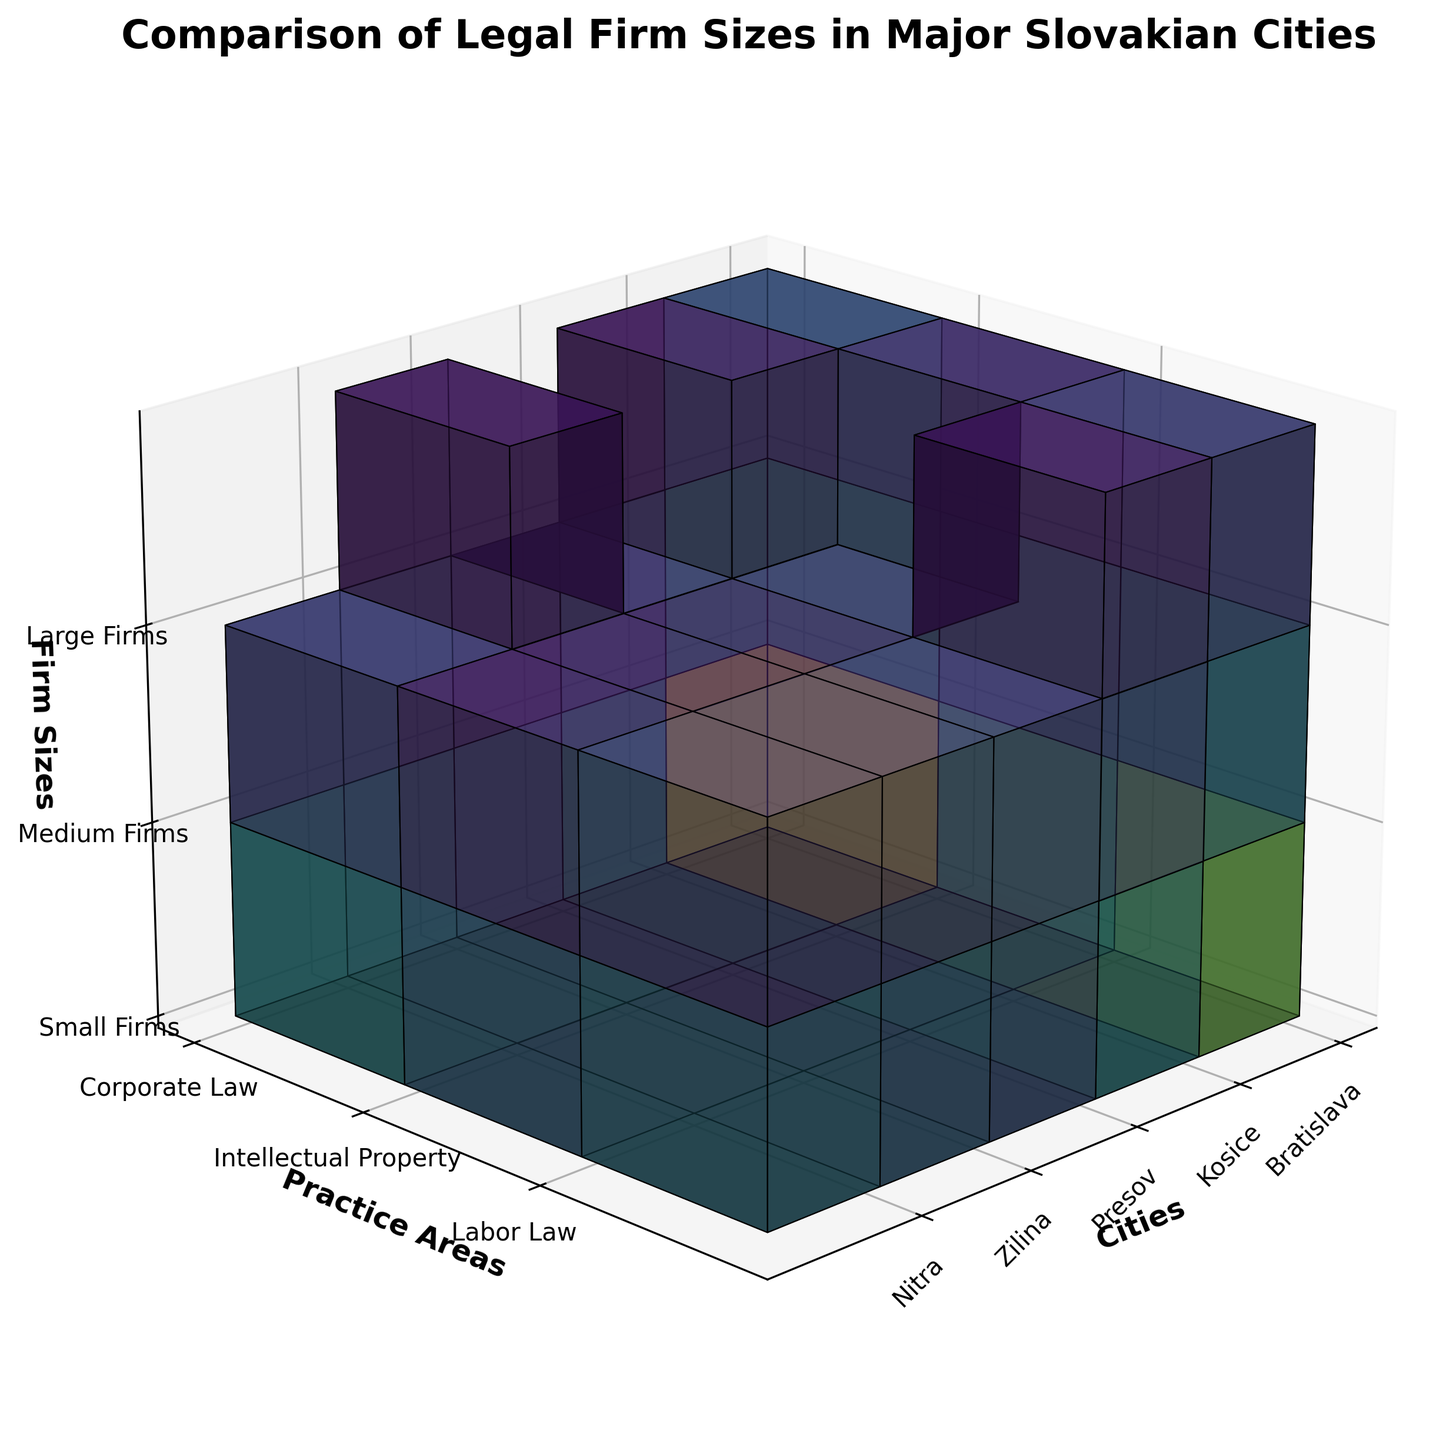What cities are compared in the figure? The x-axis represents the cities compared in the figure. By looking at the labels on this axis, we can see the cities are Bratislava, Kosice, Presov, Zilina, and Nitra.
Answer: Bratislava, Kosice, Presov, Zilina, Nitra Which city has the highest number of small firms in Corporate Law? To determine this, we need to look at the voxel height corresponding to small firms in Corporate Law for each city. The city with the highest voxel in this dimension is Bratislava.
Answer: Bratislava What is the total number of firms in Intellectual Property practice areas in Kosice across all sizes? To find this, we add the numbers of small, medium, and large firms in the Intellectual Property practice area in Kosice. The numbers are 6 (small), 2 (medium), and 0 (large), so 6 + 2 + 0 = 8.
Answer: 8 Which city has no large firms in any practice area? We need to identify the city where the voxel height for large firms is zero across all practice areas. The cities to check are Kosice and Presov. Kosice has 1 large firm in Corporate Law, so Presov is the correct city where no large firm exists in any practice area.
Answer: Presov In the practice area of Labor Law, which city has more medium firms: Bratislava or Nitra? By comparing the voxel height for medium firms in the Labor Law practice area for both cities, we see that Bratislava has 6 medium firms, while Nitra has 2. Therefore, Bratislava has more medium firms.
Answer: Bratislava How many more small firms are there in Corporate Law in Bratislava than in Zilina? We look at the number of small firms in Corporate Law for both cities. Bratislava has 15 small firms, and Zilina has 6. The difference is 15 - 6 = 9.
Answer: 9 Which practice area has the largest discrepancy in the number of firms between Bratislava and Kosice? We compare the total number of firms in each practice area between the two cities. For Corporate Law, the difference is 27 - 13 = 14. For Intellectual Property, the difference is 17 - 8 = 9. For Labor Law, the difference is 21 - 11 = 10. So, Corporate Law has the largest discrepancy of 14.
Answer: Corporate Law Are there any practice areas in Presov where the number of firms is non-zero in all sizes (small, medium, and large)? We need to check if any practice area in Presov has non-zero values for small, medium, and large firms. A quick inspection reveals that all practice areas in Presov (Corporate Law, Intellectual Property, Labor Law) have no large firms, so none of them are non-zero in all sizes.
Answer: No Which city has the lowest number of medium firms in Intellectual Property practice? By examining the voxel height for medium firms in the Intellectual Property practice area, we see that Presov and Zilina both have 1 medium firm, which is the lowest.
Answer: Presov, Zilina Which city has more total firms across all practice areas: Nitra or Zilina? Sum the total number of firms across all practice areas for both cities. For Nitra: 7+3+0 (Corporate Law) + 5+1+0 (Intellectual Property) + 6+2+0 (Labor Law) = 24. For Zilina: 6+3+1 (Corporate Law) + 4+1+0 (Intellectual Property) + 5+2+0 (Labor Law) = 22. Nitra has more firms.
Answer: Nitra 